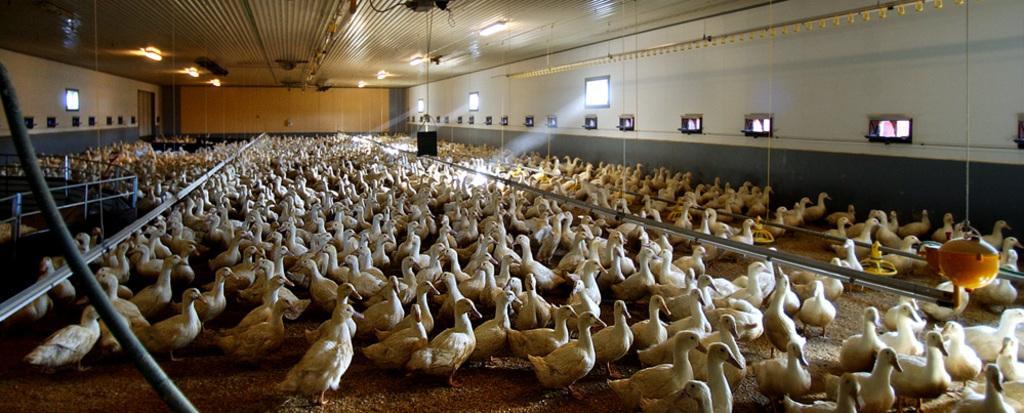Could you give a brief overview of what you see in this image? In this image I can see group of white color birds on the ground. Here I can see a wall which has windows and some other objects. I can also see a fence and lights on the ceilings. 